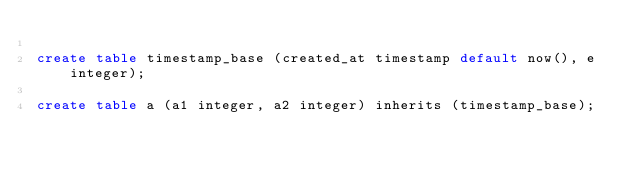Convert code to text. <code><loc_0><loc_0><loc_500><loc_500><_SQL_>
create table timestamp_base (created_at timestamp default now(), e integer);

create table a (a1 integer, a2 integer) inherits (timestamp_base);</code> 